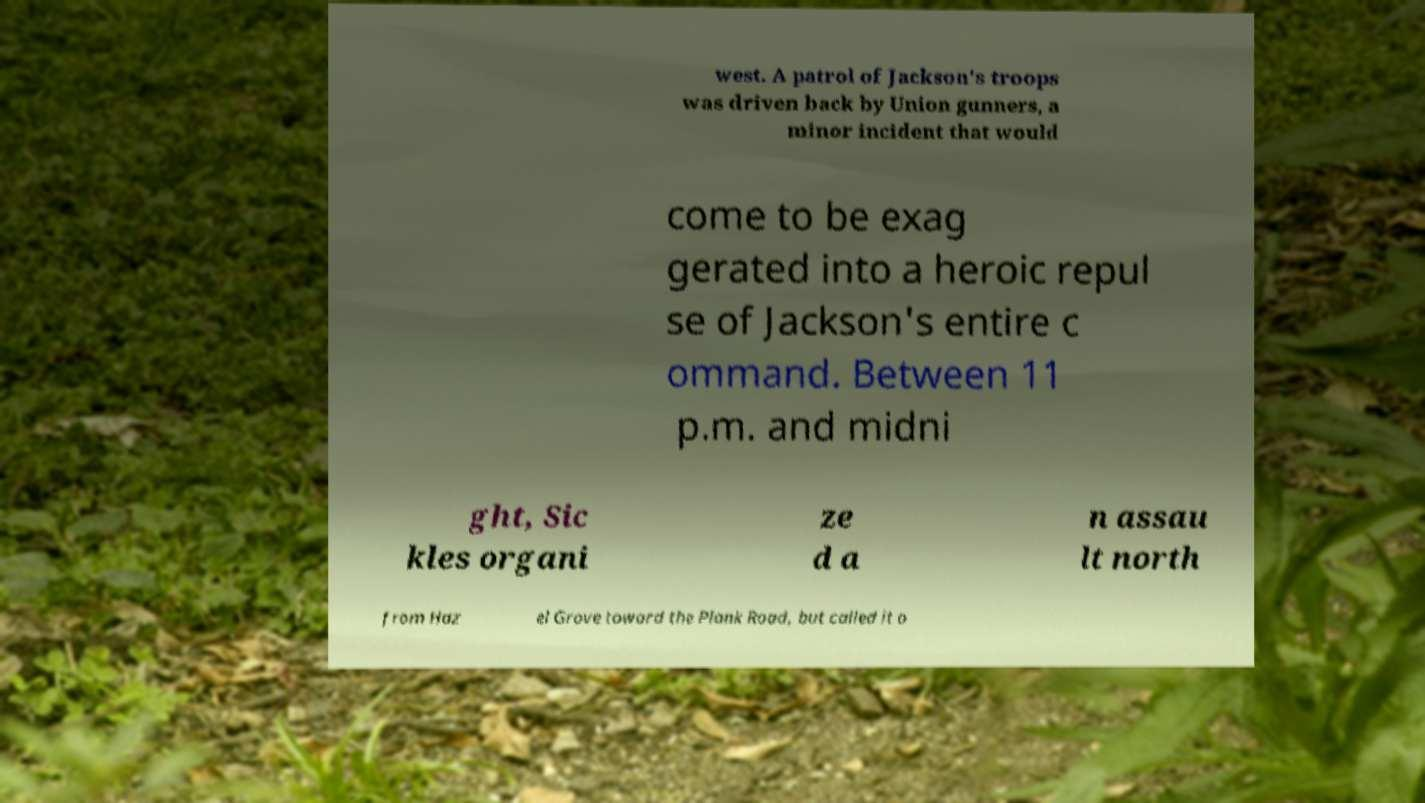For documentation purposes, I need the text within this image transcribed. Could you provide that? west. A patrol of Jackson's troops was driven back by Union gunners, a minor incident that would come to be exag gerated into a heroic repul se of Jackson's entire c ommand. Between 11 p.m. and midni ght, Sic kles organi ze d a n assau lt north from Haz el Grove toward the Plank Road, but called it o 